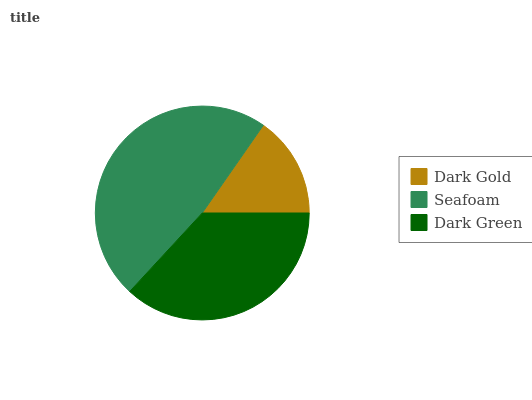Is Dark Gold the minimum?
Answer yes or no. Yes. Is Seafoam the maximum?
Answer yes or no. Yes. Is Dark Green the minimum?
Answer yes or no. No. Is Dark Green the maximum?
Answer yes or no. No. Is Seafoam greater than Dark Green?
Answer yes or no. Yes. Is Dark Green less than Seafoam?
Answer yes or no. Yes. Is Dark Green greater than Seafoam?
Answer yes or no. No. Is Seafoam less than Dark Green?
Answer yes or no. No. Is Dark Green the high median?
Answer yes or no. Yes. Is Dark Green the low median?
Answer yes or no. Yes. Is Dark Gold the high median?
Answer yes or no. No. Is Seafoam the low median?
Answer yes or no. No. 